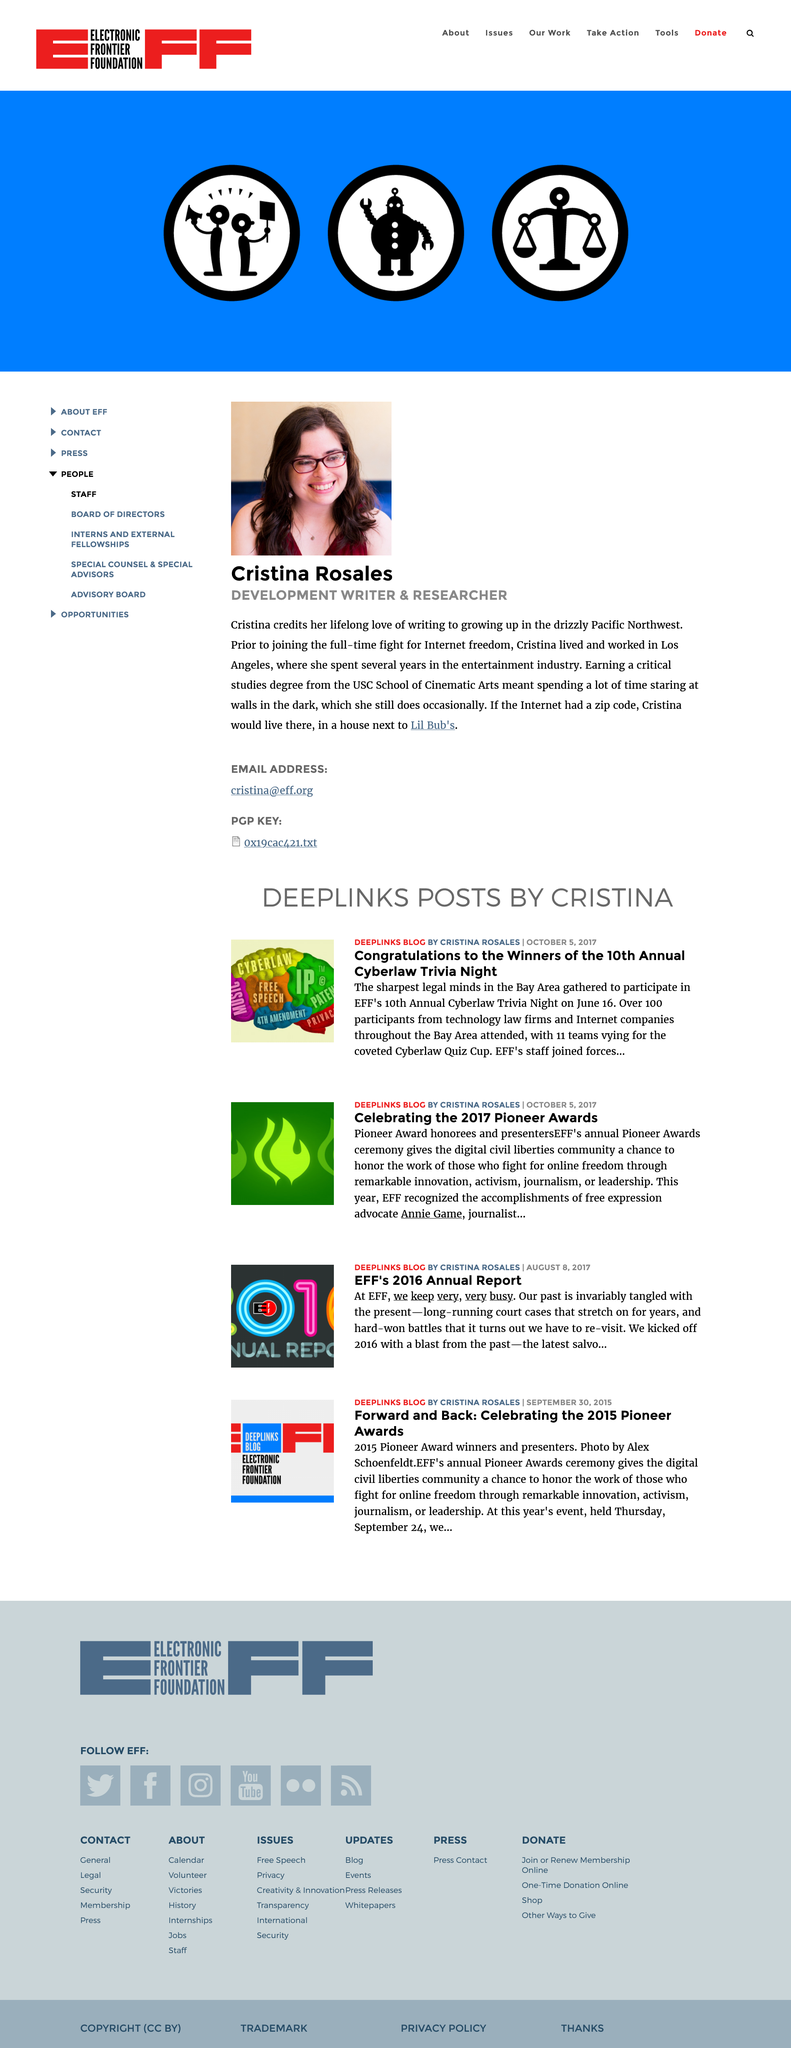Specify some key components in this picture. The person in the image is Cristina Rosales. Cristina Rosales earned her critical studies degree from the prestigious USC School of Cinematic Arts. Cristina Rosales grew up in the Pacific Northwest. 